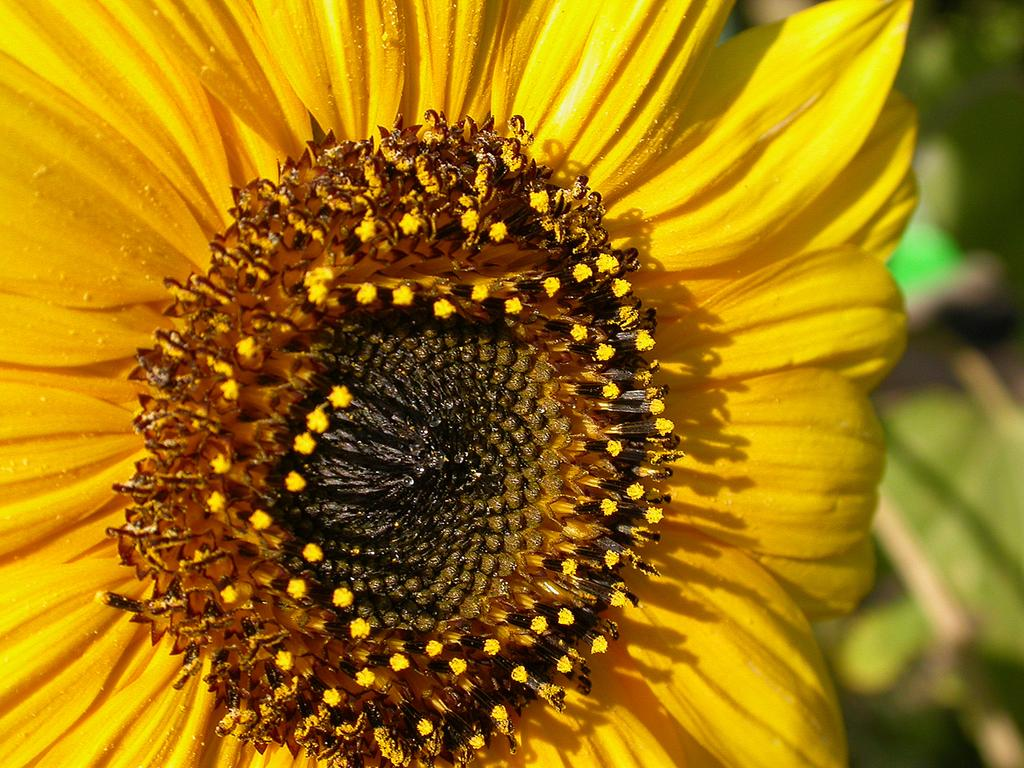What is the main subject of the image? There is a sunflower in the center of the image. Can you describe the sunflower in the image? The sunflower is the main subject and is located in the center of the image. What type of cake is being served at the sunflower's party in the image? There is no cake or party present in the image; it only features a sunflower. 